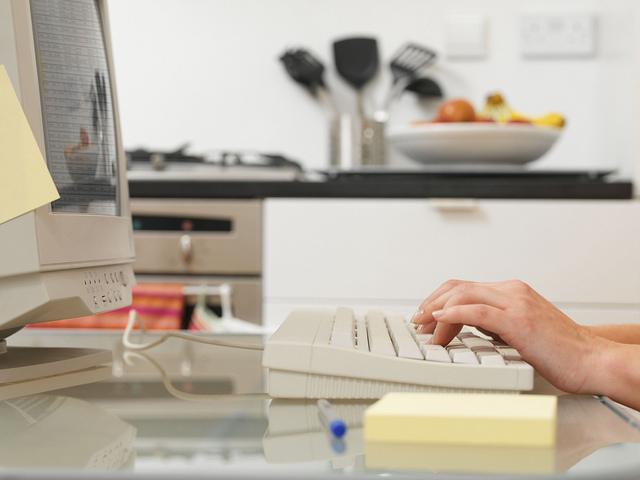Are monitors like the one depicted here very common in 2015?
Answer briefly. No. How many spatulas are there?
Concise answer only. 2. Is there a reflection in the computer screen?
Give a very brief answer. Yes. 